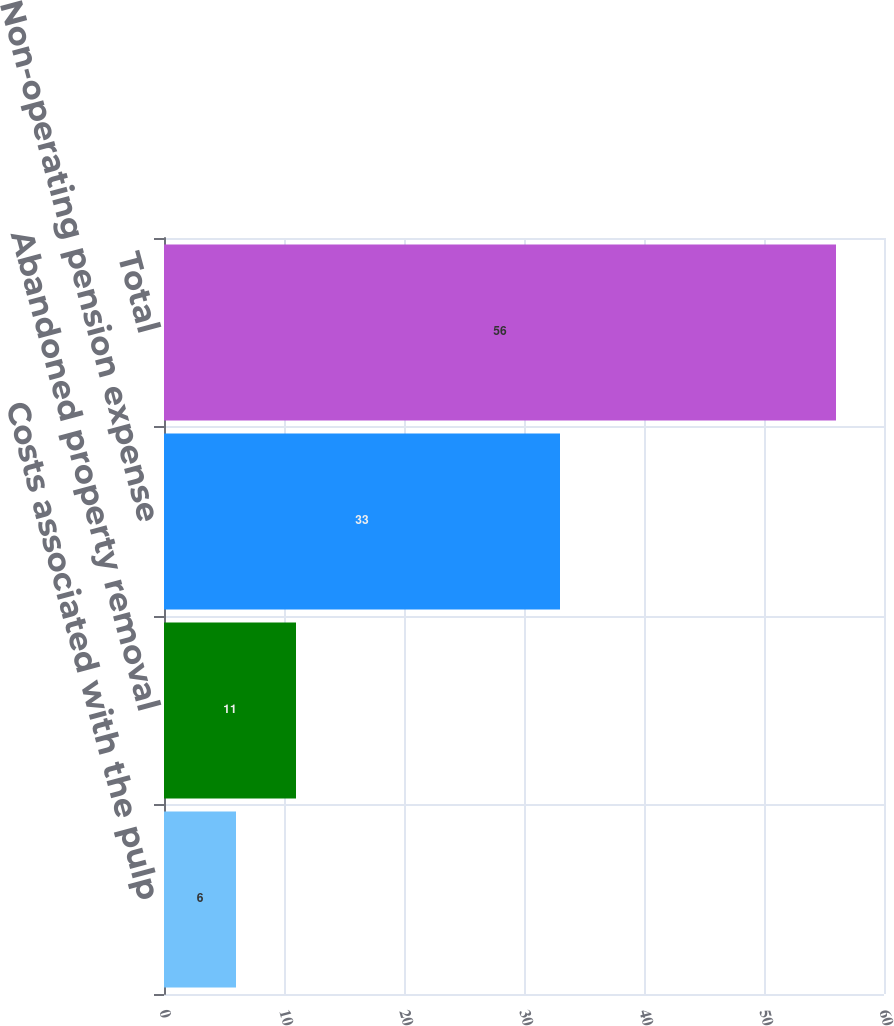<chart> <loc_0><loc_0><loc_500><loc_500><bar_chart><fcel>Costs associated with the pulp<fcel>Abandoned property removal<fcel>Non-operating pension expense<fcel>Total<nl><fcel>6<fcel>11<fcel>33<fcel>56<nl></chart> 